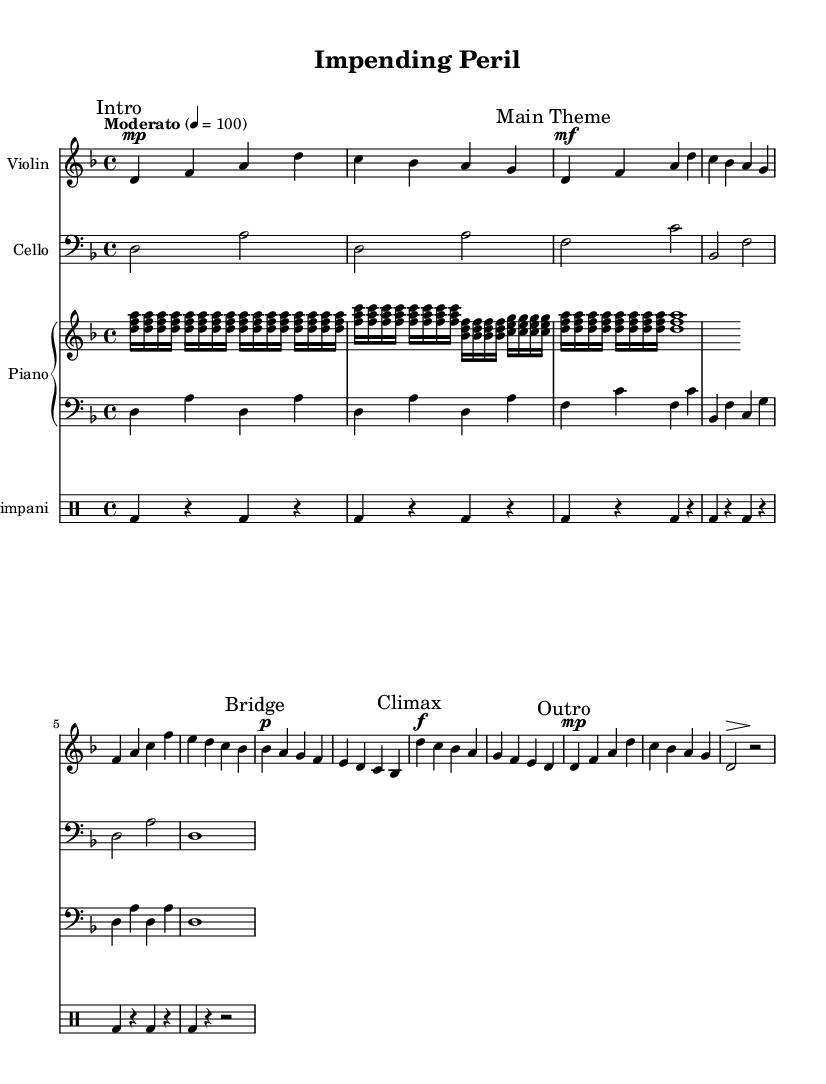What is the key signature of this music? The key signature indicates that there are two flats present in the music, which is characteristic of the key of D minor.
Answer: D minor What is the time signature of this piece? The time signature is represented by the numbers at the beginning of the score, showing there are four beats in each measure and the quarter note gets one beat, which is established as 4/4 time.
Answer: 4/4 What is the tempo marking given in the score? The tempo is indicated at the beginning of the piece, specifying it to be played at a moderato pace, which corresponds to 100 beats per minute.
Answer: Moderato 4 = 100 How many sections are there in the music? By analyzing the markings throughout the piece, we observe four distinct sections: Intro, Main Theme, Bridge, Climax, and Outro, indicating there are five sections in total.
Answer: 5 What is the dynamic marking at the Climax section? The Climax section contains a dynamic marking that shows it should be played fortissimo, reflected by the symbol indicating that this part should be performed loudly.
Answer: fortissimo Which instrument plays the main theme? The main theme is assigned to the violin, as indicated in the score where the violin staff contains the first prominent melody noted.
Answer: Violin What is the rhythmic figure used for the Timpani throughout the piece? The Timpani section consistently plays a pattern consisting of a bass drum hit on the first beat followed by rests, creating a steady and suspenseful rhythm to accompany the other parts.
Answer: Bass drum 